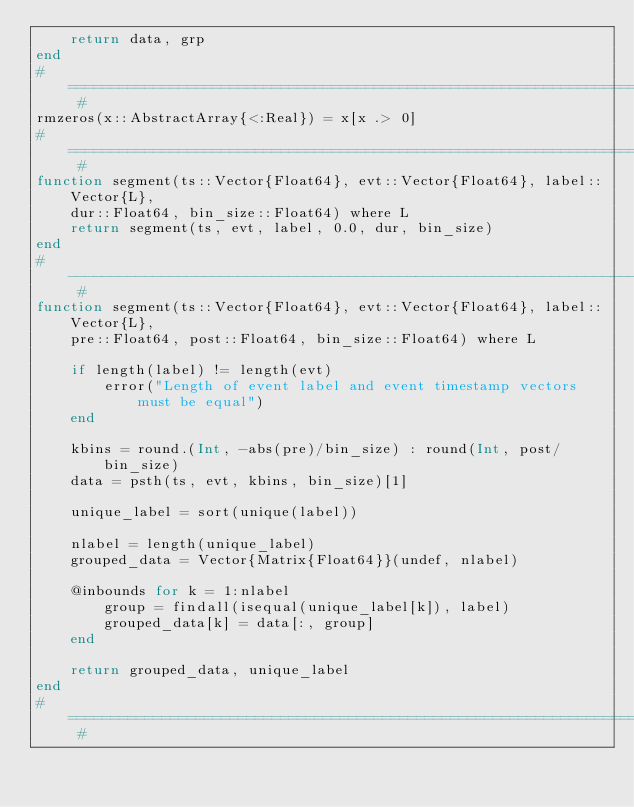<code> <loc_0><loc_0><loc_500><loc_500><_Julia_>    return data, grp
end
# ============================================================================ #
rmzeros(x::AbstractArray{<:Real}) = x[x .> 0]
# ============================================================================ #
function segment(ts::Vector{Float64}, evt::Vector{Float64}, label::Vector{L},
    dur::Float64, bin_size::Float64) where L
    return segment(ts, evt, label, 0.0, dur, bin_size)
end
# ---------------------------------------------------------------------------- #
function segment(ts::Vector{Float64}, evt::Vector{Float64}, label::Vector{L},
    pre::Float64, post::Float64, bin_size::Float64) where L

    if length(label) != length(evt)
        error("Length of event label and event timestamp vectors must be equal")
    end

    kbins = round.(Int, -abs(pre)/bin_size) : round(Int, post/bin_size)
    data = psth(ts, evt, kbins, bin_size)[1]

    unique_label = sort(unique(label))

    nlabel = length(unique_label)
    grouped_data = Vector{Matrix{Float64}}(undef, nlabel)

    @inbounds for k = 1:nlabel
        group = findall(isequal(unique_label[k]), label)
        grouped_data[k] = data[:, group]
    end

    return grouped_data, unique_label
end
# ============================================================================ #
</code> 